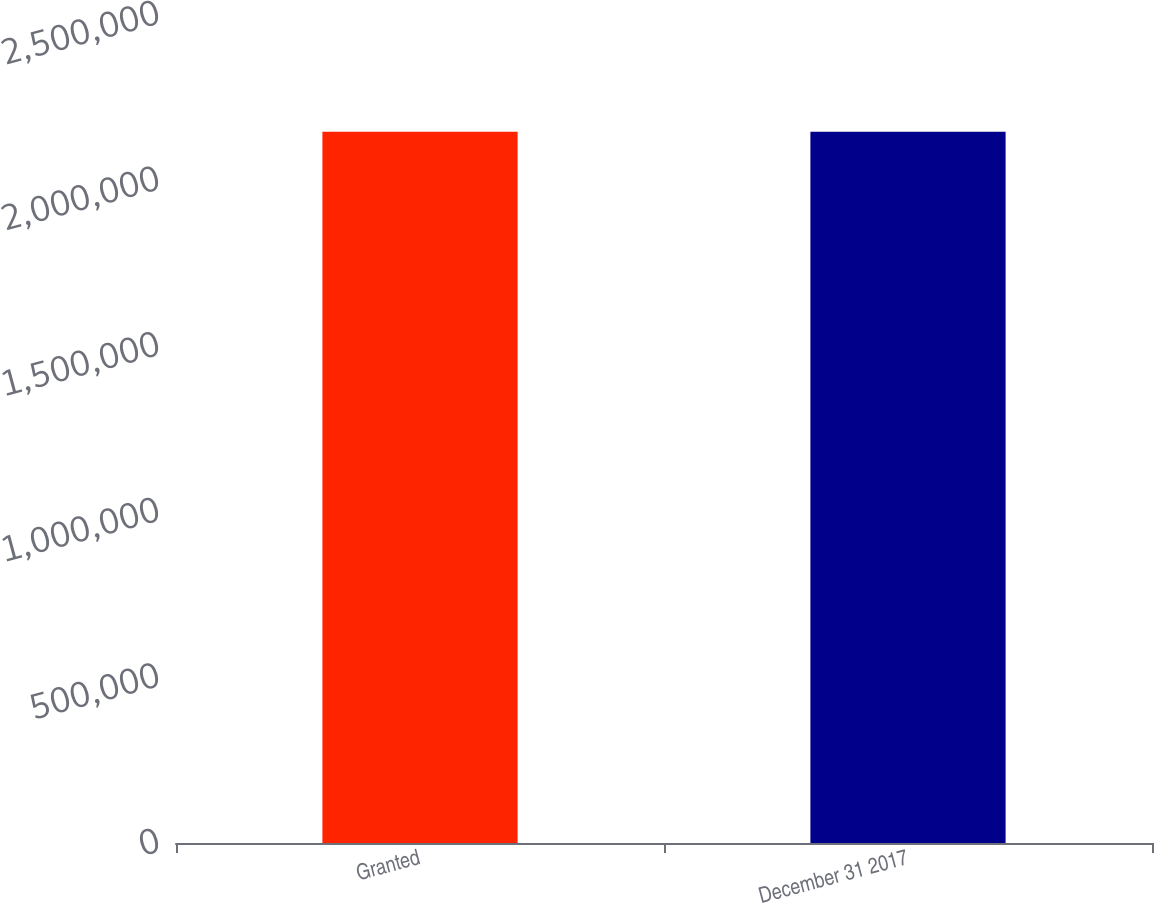Convert chart to OTSL. <chart><loc_0><loc_0><loc_500><loc_500><bar_chart><fcel>Granted<fcel>December 31 2017<nl><fcel>2.14756e+06<fcel>2.14756e+06<nl></chart> 